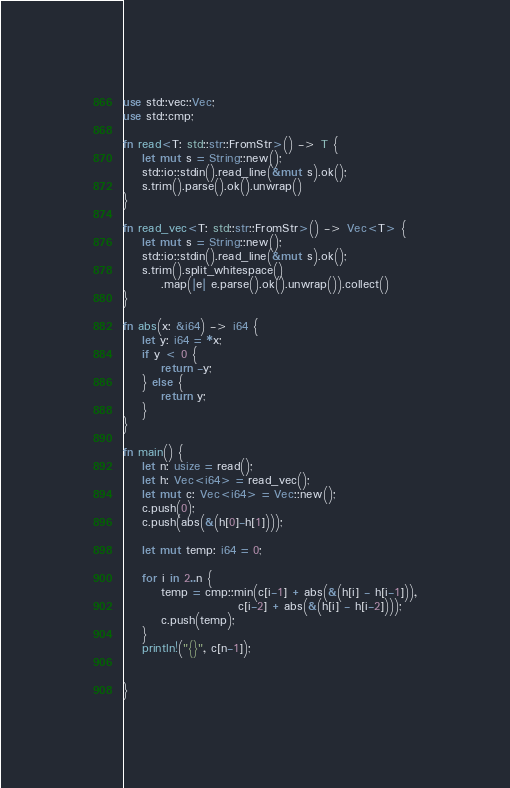Convert code to text. <code><loc_0><loc_0><loc_500><loc_500><_Rust_>use std::vec::Vec;
use std::cmp;

fn read<T: std::str::FromStr>() -> T {
    let mut s = String::new();
    std::io::stdin().read_line(&mut s).ok();
    s.trim().parse().ok().unwrap()
}

fn read_vec<T: std::str::FromStr>() -> Vec<T> {
    let mut s = String::new();
    std::io::stdin().read_line(&mut s).ok();
    s.trim().split_whitespace()
        .map(|e| e.parse().ok().unwrap()).collect()
}

fn abs(x: &i64) -> i64 {
    let y: i64 = *x;
    if y < 0 {
        return -y;
    } else {
        return y;
    }
}

fn main() {
    let n: usize = read();
    let h: Vec<i64> = read_vec();
    let mut c: Vec<i64> = Vec::new();
    c.push(0);
    c.push(abs(&(h[0]-h[1])));

    let mut temp: i64 = 0;

    for i in 2..n {
        temp = cmp::min(c[i-1] + abs(&(h[i] - h[i-1])),
                        c[i-2] + abs(&(h[i] - h[i-2])));
        c.push(temp);
    }
    println!("{}", c[n-1]);


}
</code> 